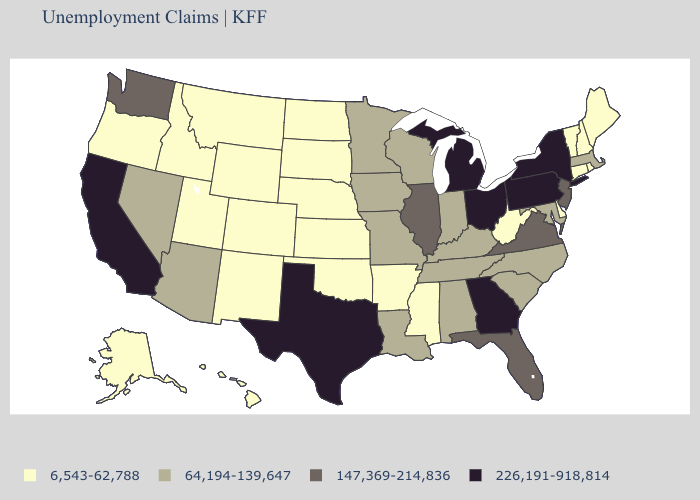What is the highest value in the Northeast ?
Write a very short answer. 226,191-918,814. What is the lowest value in the South?
Quick response, please. 6,543-62,788. What is the value of Texas?
Short answer required. 226,191-918,814. What is the value of Oklahoma?
Be succinct. 6,543-62,788. Which states have the highest value in the USA?
Write a very short answer. California, Georgia, Michigan, New York, Ohio, Pennsylvania, Texas. Name the states that have a value in the range 6,543-62,788?
Short answer required. Alaska, Arkansas, Colorado, Connecticut, Delaware, Hawaii, Idaho, Kansas, Maine, Mississippi, Montana, Nebraska, New Hampshire, New Mexico, North Dakota, Oklahoma, Oregon, Rhode Island, South Dakota, Utah, Vermont, West Virginia, Wyoming. Does the map have missing data?
Answer briefly. No. What is the lowest value in the USA?
Write a very short answer. 6,543-62,788. Does the map have missing data?
Short answer required. No. Does Massachusetts have the lowest value in the USA?
Write a very short answer. No. Does Missouri have the highest value in the MidWest?
Give a very brief answer. No. What is the value of New Hampshire?
Concise answer only. 6,543-62,788. Does the map have missing data?
Quick response, please. No. What is the value of Texas?
Be succinct. 226,191-918,814. Does North Dakota have the same value as Vermont?
Keep it brief. Yes. 